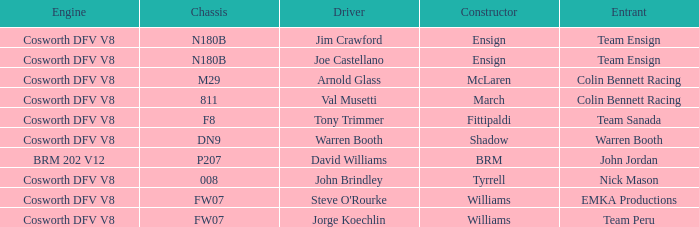Which engine is employed by colin bennett racing with an 811 chassis? Cosworth DFV V8. 